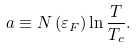<formula> <loc_0><loc_0><loc_500><loc_500>a \equiv N \left ( \varepsilon _ { F } \right ) \ln { \frac { T } { T _ { c } } } .</formula> 